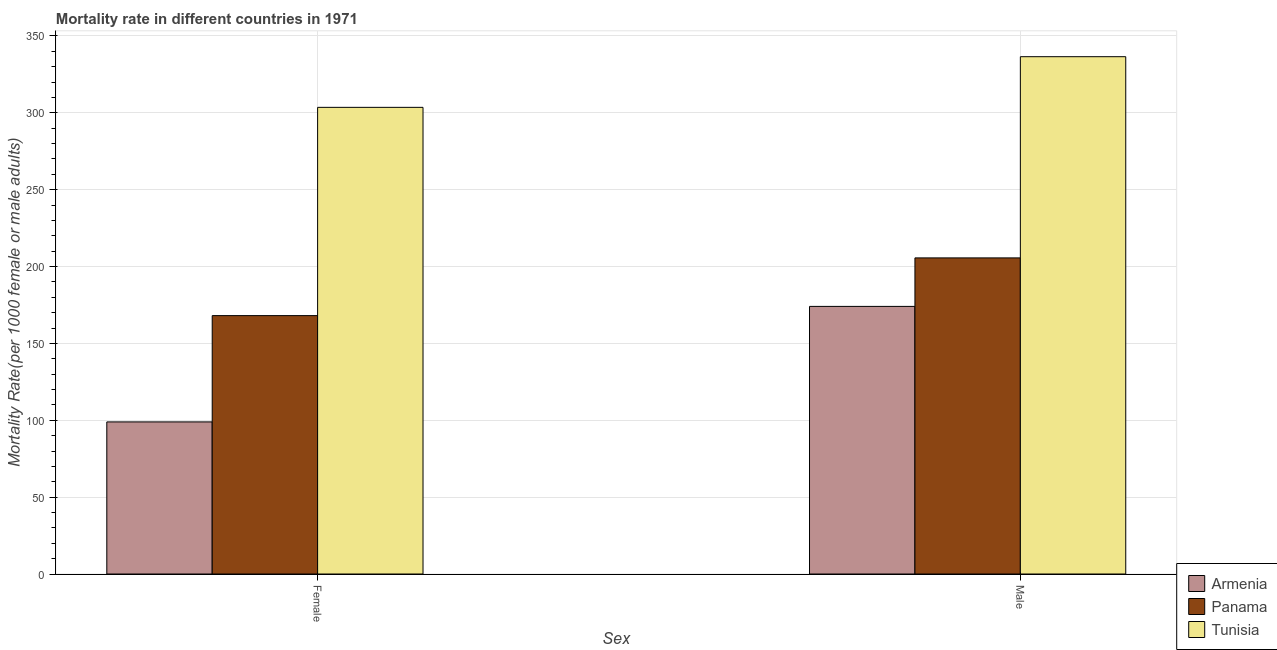How many groups of bars are there?
Your response must be concise. 2. How many bars are there on the 2nd tick from the right?
Your response must be concise. 3. What is the female mortality rate in Tunisia?
Offer a very short reply. 303.52. Across all countries, what is the maximum male mortality rate?
Make the answer very short. 336.48. Across all countries, what is the minimum male mortality rate?
Provide a short and direct response. 174.06. In which country was the male mortality rate maximum?
Provide a short and direct response. Tunisia. In which country was the male mortality rate minimum?
Your response must be concise. Armenia. What is the total male mortality rate in the graph?
Your answer should be very brief. 716.14. What is the difference between the male mortality rate in Armenia and that in Tunisia?
Your answer should be very brief. -162.42. What is the difference between the male mortality rate in Panama and the female mortality rate in Tunisia?
Offer a very short reply. -97.92. What is the average male mortality rate per country?
Keep it short and to the point. 238.71. What is the difference between the female mortality rate and male mortality rate in Armenia?
Your response must be concise. -75.13. In how many countries, is the male mortality rate greater than 10 ?
Provide a short and direct response. 3. What is the ratio of the female mortality rate in Tunisia to that in Panama?
Make the answer very short. 1.81. Is the female mortality rate in Panama less than that in Armenia?
Provide a succinct answer. No. What does the 1st bar from the left in Male represents?
Make the answer very short. Armenia. What does the 2nd bar from the right in Female represents?
Make the answer very short. Panama. How many bars are there?
Keep it short and to the point. 6. How many countries are there in the graph?
Make the answer very short. 3. What is the difference between two consecutive major ticks on the Y-axis?
Make the answer very short. 50. Are the values on the major ticks of Y-axis written in scientific E-notation?
Keep it short and to the point. No. Does the graph contain grids?
Offer a very short reply. Yes. How many legend labels are there?
Your response must be concise. 3. How are the legend labels stacked?
Ensure brevity in your answer.  Vertical. What is the title of the graph?
Give a very brief answer. Mortality rate in different countries in 1971. Does "Europe(all income levels)" appear as one of the legend labels in the graph?
Ensure brevity in your answer.  No. What is the label or title of the X-axis?
Give a very brief answer. Sex. What is the label or title of the Y-axis?
Keep it short and to the point. Mortality Rate(per 1000 female or male adults). What is the Mortality Rate(per 1000 female or male adults) in Armenia in Female?
Give a very brief answer. 98.92. What is the Mortality Rate(per 1000 female or male adults) of Panama in Female?
Give a very brief answer. 168.06. What is the Mortality Rate(per 1000 female or male adults) in Tunisia in Female?
Ensure brevity in your answer.  303.52. What is the Mortality Rate(per 1000 female or male adults) of Armenia in Male?
Provide a short and direct response. 174.06. What is the Mortality Rate(per 1000 female or male adults) of Panama in Male?
Give a very brief answer. 205.6. What is the Mortality Rate(per 1000 female or male adults) of Tunisia in Male?
Offer a very short reply. 336.48. Across all Sex, what is the maximum Mortality Rate(per 1000 female or male adults) in Armenia?
Keep it short and to the point. 174.06. Across all Sex, what is the maximum Mortality Rate(per 1000 female or male adults) of Panama?
Ensure brevity in your answer.  205.6. Across all Sex, what is the maximum Mortality Rate(per 1000 female or male adults) in Tunisia?
Your answer should be compact. 336.48. Across all Sex, what is the minimum Mortality Rate(per 1000 female or male adults) of Armenia?
Provide a succinct answer. 98.92. Across all Sex, what is the minimum Mortality Rate(per 1000 female or male adults) in Panama?
Make the answer very short. 168.06. Across all Sex, what is the minimum Mortality Rate(per 1000 female or male adults) in Tunisia?
Your answer should be very brief. 303.52. What is the total Mortality Rate(per 1000 female or male adults) of Armenia in the graph?
Your response must be concise. 272.98. What is the total Mortality Rate(per 1000 female or male adults) in Panama in the graph?
Offer a very short reply. 373.66. What is the total Mortality Rate(per 1000 female or male adults) in Tunisia in the graph?
Offer a terse response. 640. What is the difference between the Mortality Rate(per 1000 female or male adults) of Armenia in Female and that in Male?
Your response must be concise. -75.13. What is the difference between the Mortality Rate(per 1000 female or male adults) of Panama in Female and that in Male?
Provide a short and direct response. -37.55. What is the difference between the Mortality Rate(per 1000 female or male adults) of Tunisia in Female and that in Male?
Make the answer very short. -32.95. What is the difference between the Mortality Rate(per 1000 female or male adults) of Armenia in Female and the Mortality Rate(per 1000 female or male adults) of Panama in Male?
Provide a succinct answer. -106.68. What is the difference between the Mortality Rate(per 1000 female or male adults) of Armenia in Female and the Mortality Rate(per 1000 female or male adults) of Tunisia in Male?
Provide a succinct answer. -237.55. What is the difference between the Mortality Rate(per 1000 female or male adults) of Panama in Female and the Mortality Rate(per 1000 female or male adults) of Tunisia in Male?
Your answer should be very brief. -168.42. What is the average Mortality Rate(per 1000 female or male adults) in Armenia per Sex?
Offer a terse response. 136.49. What is the average Mortality Rate(per 1000 female or male adults) in Panama per Sex?
Provide a succinct answer. 186.83. What is the average Mortality Rate(per 1000 female or male adults) in Tunisia per Sex?
Keep it short and to the point. 320. What is the difference between the Mortality Rate(per 1000 female or male adults) in Armenia and Mortality Rate(per 1000 female or male adults) in Panama in Female?
Keep it short and to the point. -69.13. What is the difference between the Mortality Rate(per 1000 female or male adults) of Armenia and Mortality Rate(per 1000 female or male adults) of Tunisia in Female?
Keep it short and to the point. -204.6. What is the difference between the Mortality Rate(per 1000 female or male adults) of Panama and Mortality Rate(per 1000 female or male adults) of Tunisia in Female?
Provide a succinct answer. -135.47. What is the difference between the Mortality Rate(per 1000 female or male adults) in Armenia and Mortality Rate(per 1000 female or male adults) in Panama in Male?
Make the answer very short. -31.55. What is the difference between the Mortality Rate(per 1000 female or male adults) of Armenia and Mortality Rate(per 1000 female or male adults) of Tunisia in Male?
Your answer should be compact. -162.42. What is the difference between the Mortality Rate(per 1000 female or male adults) in Panama and Mortality Rate(per 1000 female or male adults) in Tunisia in Male?
Keep it short and to the point. -130.87. What is the ratio of the Mortality Rate(per 1000 female or male adults) of Armenia in Female to that in Male?
Keep it short and to the point. 0.57. What is the ratio of the Mortality Rate(per 1000 female or male adults) of Panama in Female to that in Male?
Keep it short and to the point. 0.82. What is the ratio of the Mortality Rate(per 1000 female or male adults) of Tunisia in Female to that in Male?
Offer a terse response. 0.9. What is the difference between the highest and the second highest Mortality Rate(per 1000 female or male adults) of Armenia?
Your response must be concise. 75.13. What is the difference between the highest and the second highest Mortality Rate(per 1000 female or male adults) of Panama?
Offer a very short reply. 37.55. What is the difference between the highest and the second highest Mortality Rate(per 1000 female or male adults) in Tunisia?
Make the answer very short. 32.95. What is the difference between the highest and the lowest Mortality Rate(per 1000 female or male adults) in Armenia?
Your answer should be compact. 75.13. What is the difference between the highest and the lowest Mortality Rate(per 1000 female or male adults) in Panama?
Ensure brevity in your answer.  37.55. What is the difference between the highest and the lowest Mortality Rate(per 1000 female or male adults) of Tunisia?
Offer a very short reply. 32.95. 